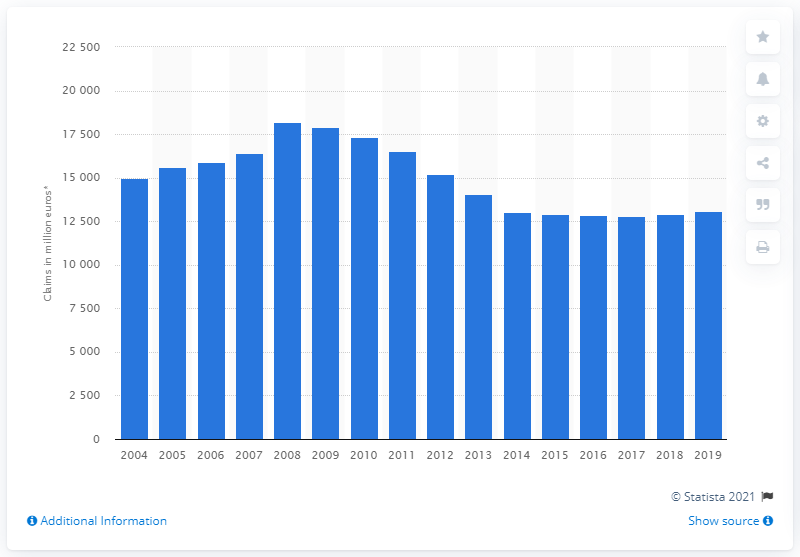Highlight a few significant elements in this photo. The value of motor claims paid in 2019 was 13,078. The total value of motor claims paid on the insurance market in 2008 was 18,210. 